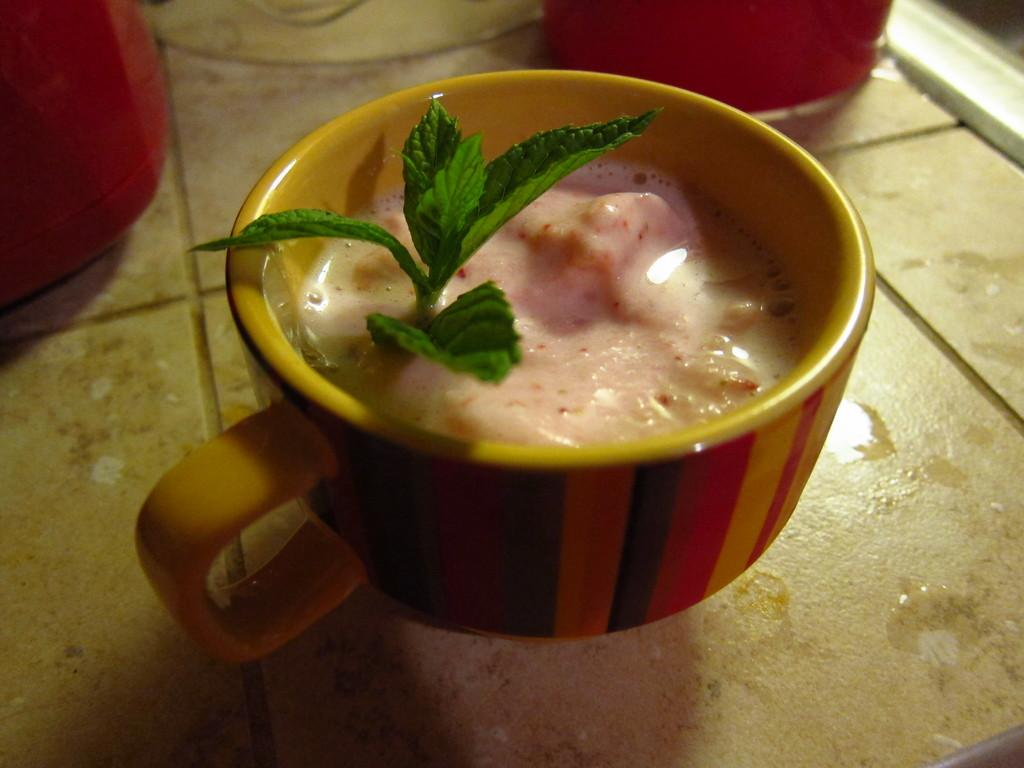What is inside the cup that is visible in the image? There is a cup with a drink and leaves in the image. What color are the two objects in the image? The two objects are red in color. What type of surface are the objects placed on in the image? The objects are placed on tiles in the image. What type of joke is being told by the wheel in the image? There is no wheel present in the image, so it is not possible to determine if a joke is being told. 